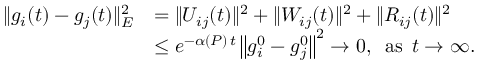<formula> <loc_0><loc_0><loc_500><loc_500>\begin{array} { r l } { \| g _ { i } ( t ) - g _ { j } ( t ) \| _ { E } ^ { 2 } } & { = \| U _ { i j } ( t ) \| ^ { 2 } + \| W _ { i j } ( t ) \| ^ { 2 } + \| R _ { i j } ( t ) \| ^ { 2 } } \\ & { \leq e ^ { - \alpha ( P ) \, t } \left \| g _ { i } ^ { 0 } - g _ { j } ^ { 0 } \right \| ^ { 2 } \to 0 , \, a s \, t \to \infty . } \end{array}</formula> 